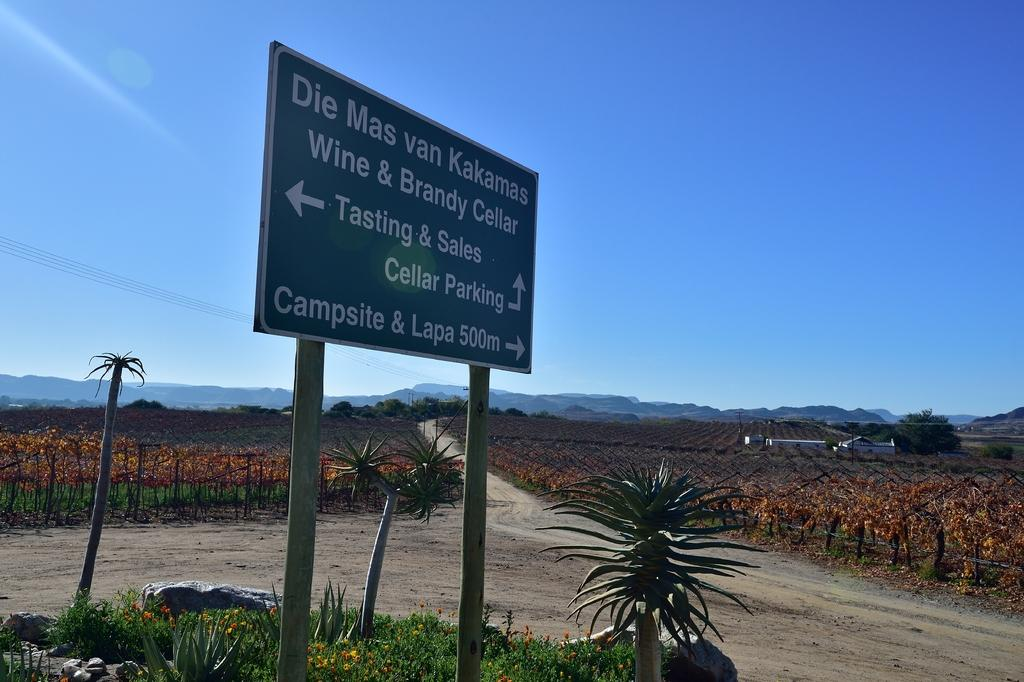What is the main object in the image? There is a sign board in the image. What type of natural elements can be seen in the image? There are plants, trees, mountains, and agricultural land visible in the image. What man-made structures are present in the image? Houses are present in the image. What else can be seen in the sky? The sky is visible in the image. How often do you need to wash the crib in the image? There is no crib present in the image. What mark can be seen on the sign board in the image? The provided facts do not mention any specific mark on the sign board, so we cannot answer this question. 